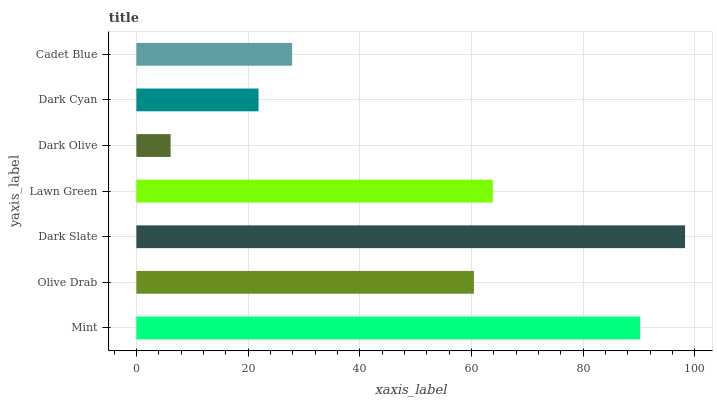Is Dark Olive the minimum?
Answer yes or no. Yes. Is Dark Slate the maximum?
Answer yes or no. Yes. Is Olive Drab the minimum?
Answer yes or no. No. Is Olive Drab the maximum?
Answer yes or no. No. Is Mint greater than Olive Drab?
Answer yes or no. Yes. Is Olive Drab less than Mint?
Answer yes or no. Yes. Is Olive Drab greater than Mint?
Answer yes or no. No. Is Mint less than Olive Drab?
Answer yes or no. No. Is Olive Drab the high median?
Answer yes or no. Yes. Is Olive Drab the low median?
Answer yes or no. Yes. Is Lawn Green the high median?
Answer yes or no. No. Is Dark Olive the low median?
Answer yes or no. No. 